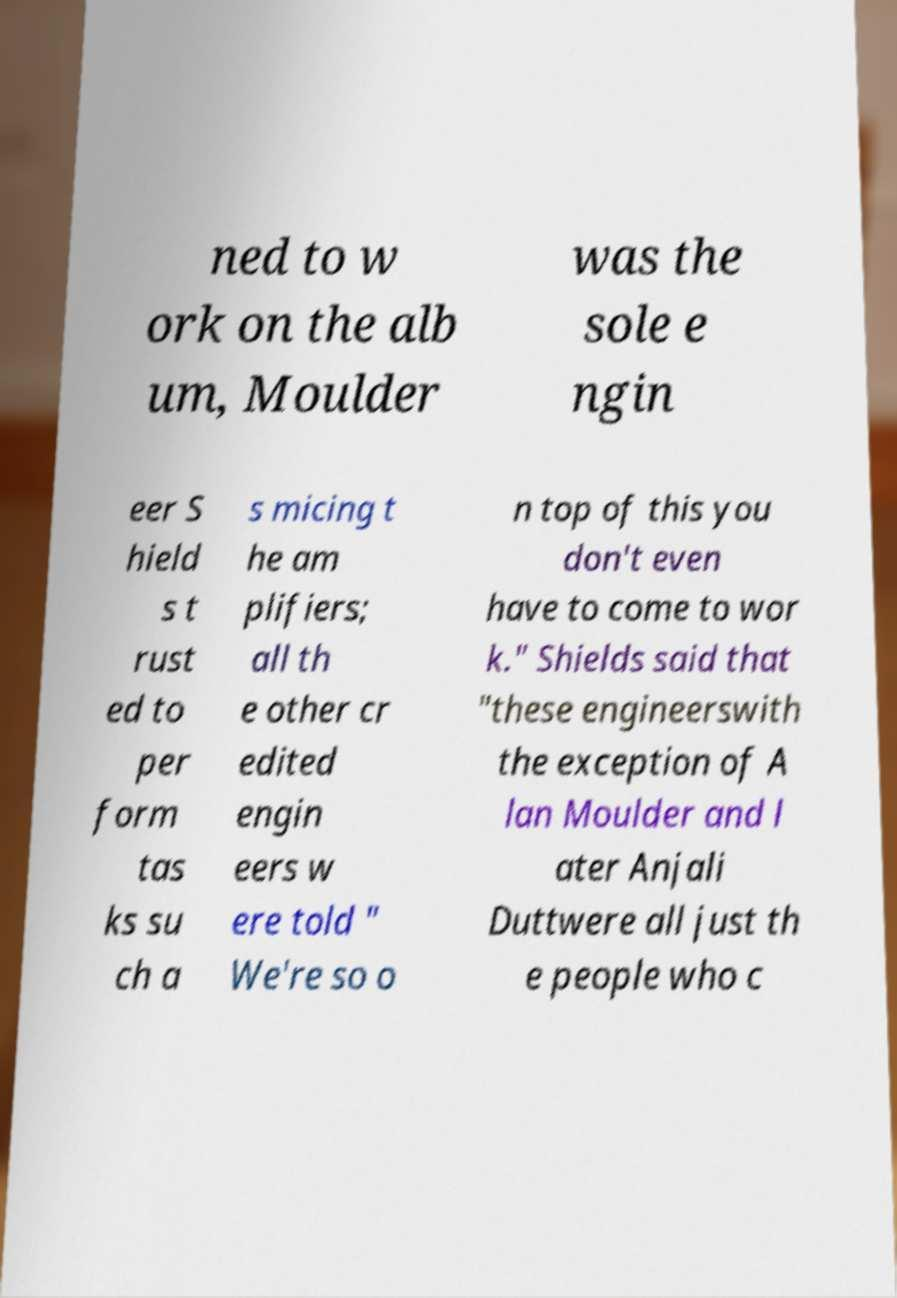Could you extract and type out the text from this image? ned to w ork on the alb um, Moulder was the sole e ngin eer S hield s t rust ed to per form tas ks su ch a s micing t he am plifiers; all th e other cr edited engin eers w ere told " We're so o n top of this you don't even have to come to wor k." Shields said that "these engineerswith the exception of A lan Moulder and l ater Anjali Duttwere all just th e people who c 